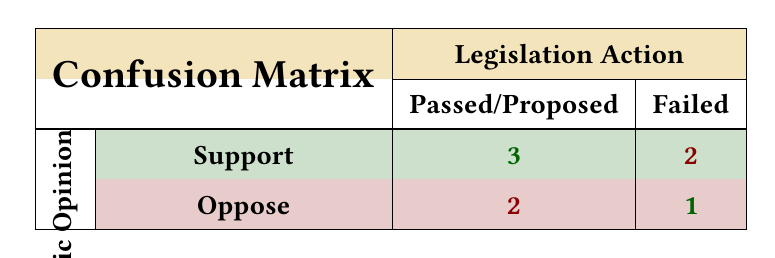What is the total number of issues for which public opinion supported the legislation? There are three issues where public opinion indicated support: Healthcare Accessibility, Minimum Wage Increase, and Education Funding. This corresponds to the "Support" row in the matrix, column "Passed/Proposed". Therefore, the total count is 3.
Answer: 3 How many issues were proposed versus failed? In the confusion matrix, there is 1 issue that was proposed (Education Funding) and 3 that failed (Climate Change Policy, Gun Control, and Pension Reform). Therefore, the count for proposed is 1 and failed is 3.
Answer: Proposed: 1, Failed: 3 Is it true that more legislation was passed than failed? To determine this, count the total number of legislation passed (5: Healthcare Accessibility, Tax Reform, Minimum Wage Increase, Immigration Policy, Education Funding) and failed (3: Climate Change Policy, Gun Control, Pension Reform). Since 5 is greater than 3, the statement is true.
Answer: Yes What is the difference between the number of issues where public opinion opposed and the number of issues that successfully passed legislation? The number of issues where public opinion opposed is 3 (Tax Reform, Pension Reform, and Immigration Policy). The number of issues that successfully passed legislation is 5. Therefore, the difference is calculated as 5 (passed) - 3 (opposed) = 2.
Answer: 2 What percentage of supported public opinion led to successful legislation? There are 3 instances of support corresponding to successful legislation out of a total of 5 instances of support. To find the percentage, (3 / 5) * 100 = 60%.
Answer: 60% 